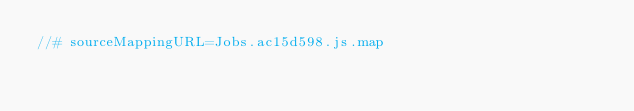Convert code to text. <code><loc_0><loc_0><loc_500><loc_500><_JavaScript_>//# sourceMappingURL=Jobs.ac15d598.js.map</code> 